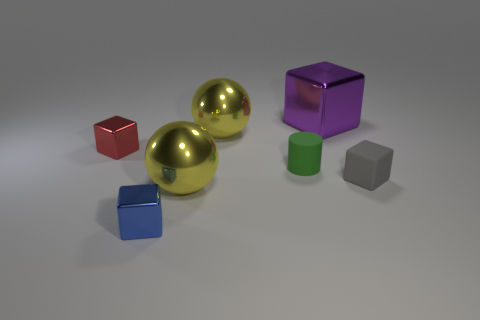Subtract all yellow blocks. Subtract all purple spheres. How many blocks are left? 4 Add 1 small shiny objects. How many objects exist? 8 Subtract all cubes. How many objects are left? 3 Add 6 large metallic balls. How many large metallic balls are left? 8 Add 2 gray blocks. How many gray blocks exist? 3 Subtract 0 cyan blocks. How many objects are left? 7 Subtract all tiny red balls. Subtract all red cubes. How many objects are left? 6 